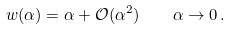<formula> <loc_0><loc_0><loc_500><loc_500>w ( \alpha ) = \alpha + \mathcal { O } ( \alpha ^ { 2 } ) \quad \alpha \to 0 \, .</formula> 